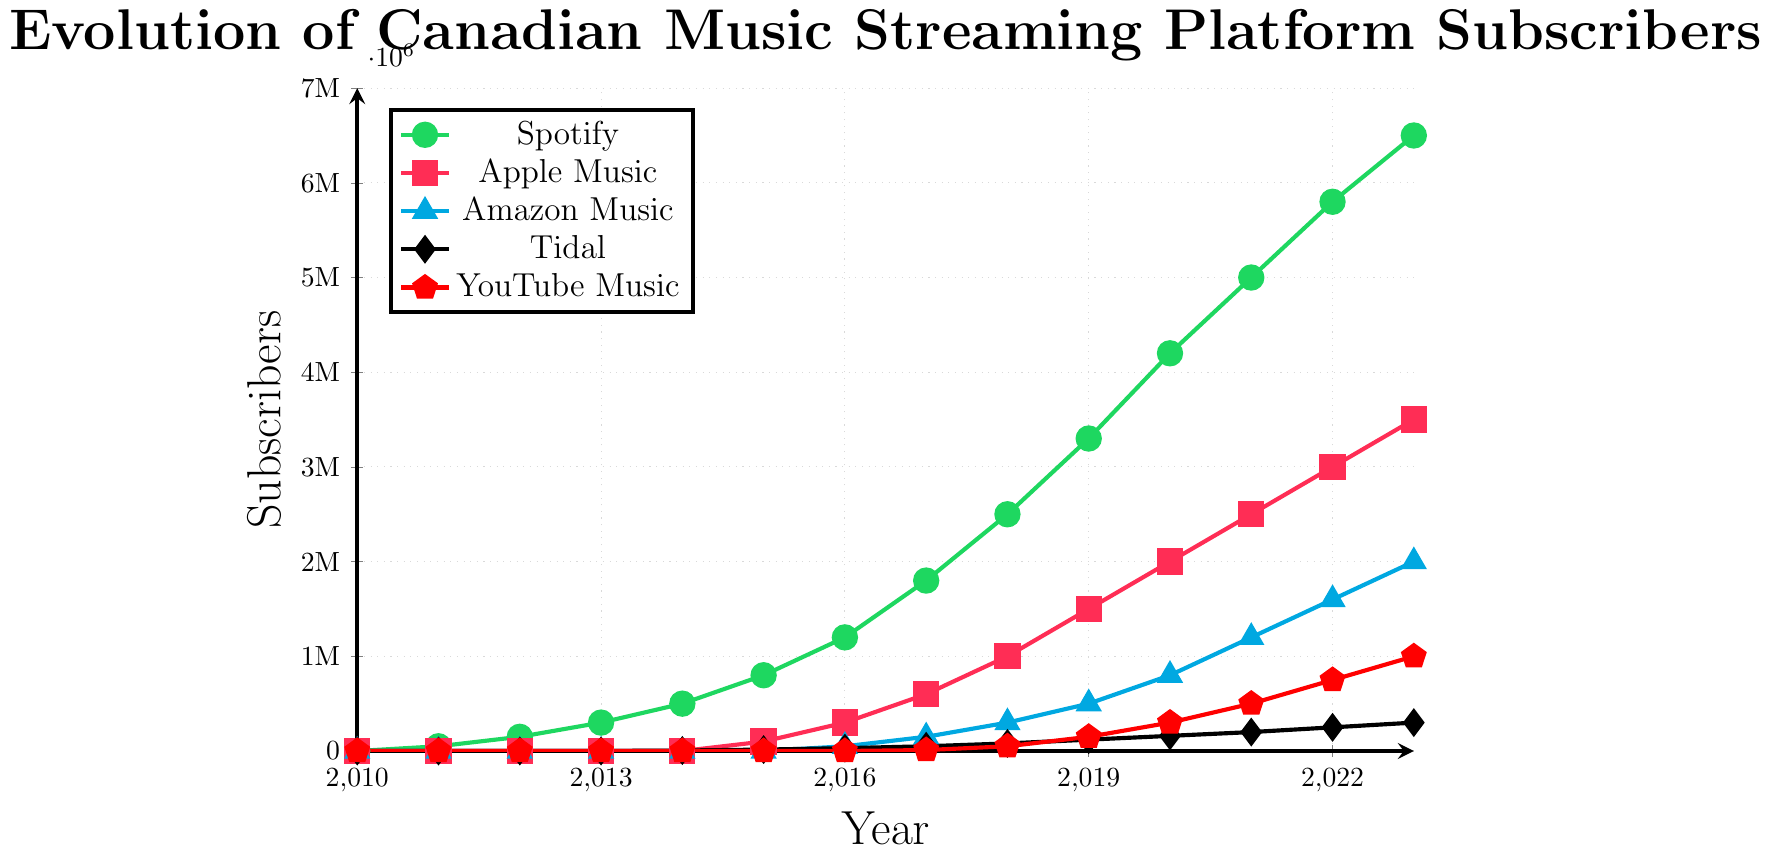Which platform saw the highest number of subscribers in 2023? To find the platform with the highest number of subscribers in 2023, look at the final data points for each platform. In 2023, Spotify has the most subscribers, depicted by the green line reaching 6.5 million.
Answer: Spotify Which two platforms had the closest number of subscribers in 2018? In 2018, compare the subscribers of all platforms. Apple Music had 1,000,000 subscribers, and Amazon Music had 300,000 subscribers. YouTube Music had 50,000, slightly more than Tidal with 80,000 subscribers. Therefore, Tidal and YouTube Music had the closest numbers.
Answer: Tidal and YouTube Music What is the difference in the number of subscribers between the most and least subscribed platforms in 2020? In 2020, the most subscribed platform is Spotify with 4,200,000, and the least is Tidal with 160,000 subscribers. The difference is calculated as 4,200,000 - 160,000.
Answer: 4,040,000 How did the number of subscribers for Apple Music change from 2015 to 2023? In 2015, Apple Music had 100,000 subscribers and in 2023 there were 3,500,000. The change is found by subtracting the first number from the second: 3,500,000 - 100,000.
Answer: Increased by 3,400,000 Which year did Amazon Music start showing a significant increase in subscribers? Observing Amazon Music's trend, marked by triangles, a notable increase began in 2017, jumping from no subscribers to 150,000 from the previous years’ zero subscriber count.
Answer: 2017 What is the average number of subscribers for YouTube Music from 2020 to 2023? Sum the number of subscribers in 2020 (300,000), 2021 (500,000), 2022 (750,000), and 2023 (1,000,000) and divide by 4. (300,000 + 500,000 + 750,000 + 1,000,000) / 4.
Answer: 637,500 Compare the number of subscribers between Spotify and Apple Music in 2021. Which was higher and by how much? In 2021, Spotify had 5,000,000 subscribers, while Apple Music had 2,500,000. The difference is 5,000,000 - 2,500,000.
Answer: Spotify, by 2,500,000 Which platform had the slowest growth from 2010 to 2023? By examining the increase over time, Tidal has the slowest growth, displayed as the line with the smallest slope and increment, starting around 2014 and only reaching 300,000 by 2023.
Answer: Tidal What is the total number of subscribers for all platforms in 2019? Add the subscribers for all platforms in 2019. Spotify (3,300,000) + Apple Music (1,500,000) + Amazon Music (500,000) + Tidal (120,000) + YouTube Music (150,000).
Answer: 5,570,000 How did the subscriber count for Spotify change between 2011 and 2016? In 2011, Spotify had 50,000 subscribers, and in 2016, it had 1,200,000. The increase is calculated by subtracting 50,000 from 1,200,000.
Answer: Increased by 1,150,000 